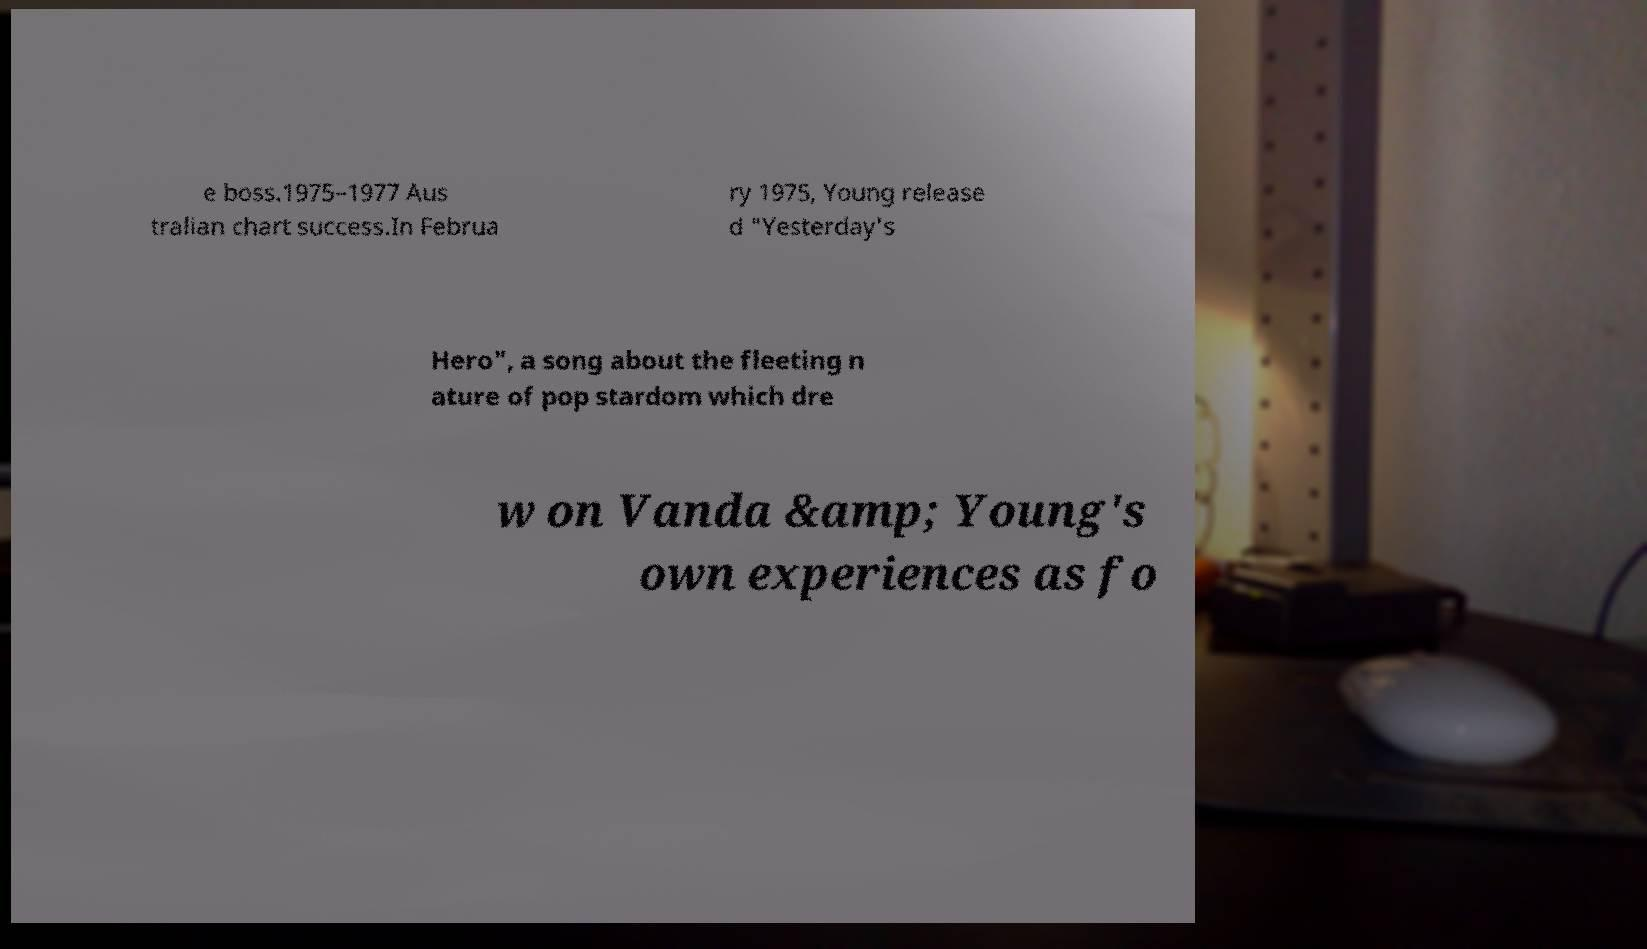Could you extract and type out the text from this image? e boss.1975–1977 Aus tralian chart success.In Februa ry 1975, Young release d "Yesterday's Hero", a song about the fleeting n ature of pop stardom which dre w on Vanda &amp; Young's own experiences as fo 